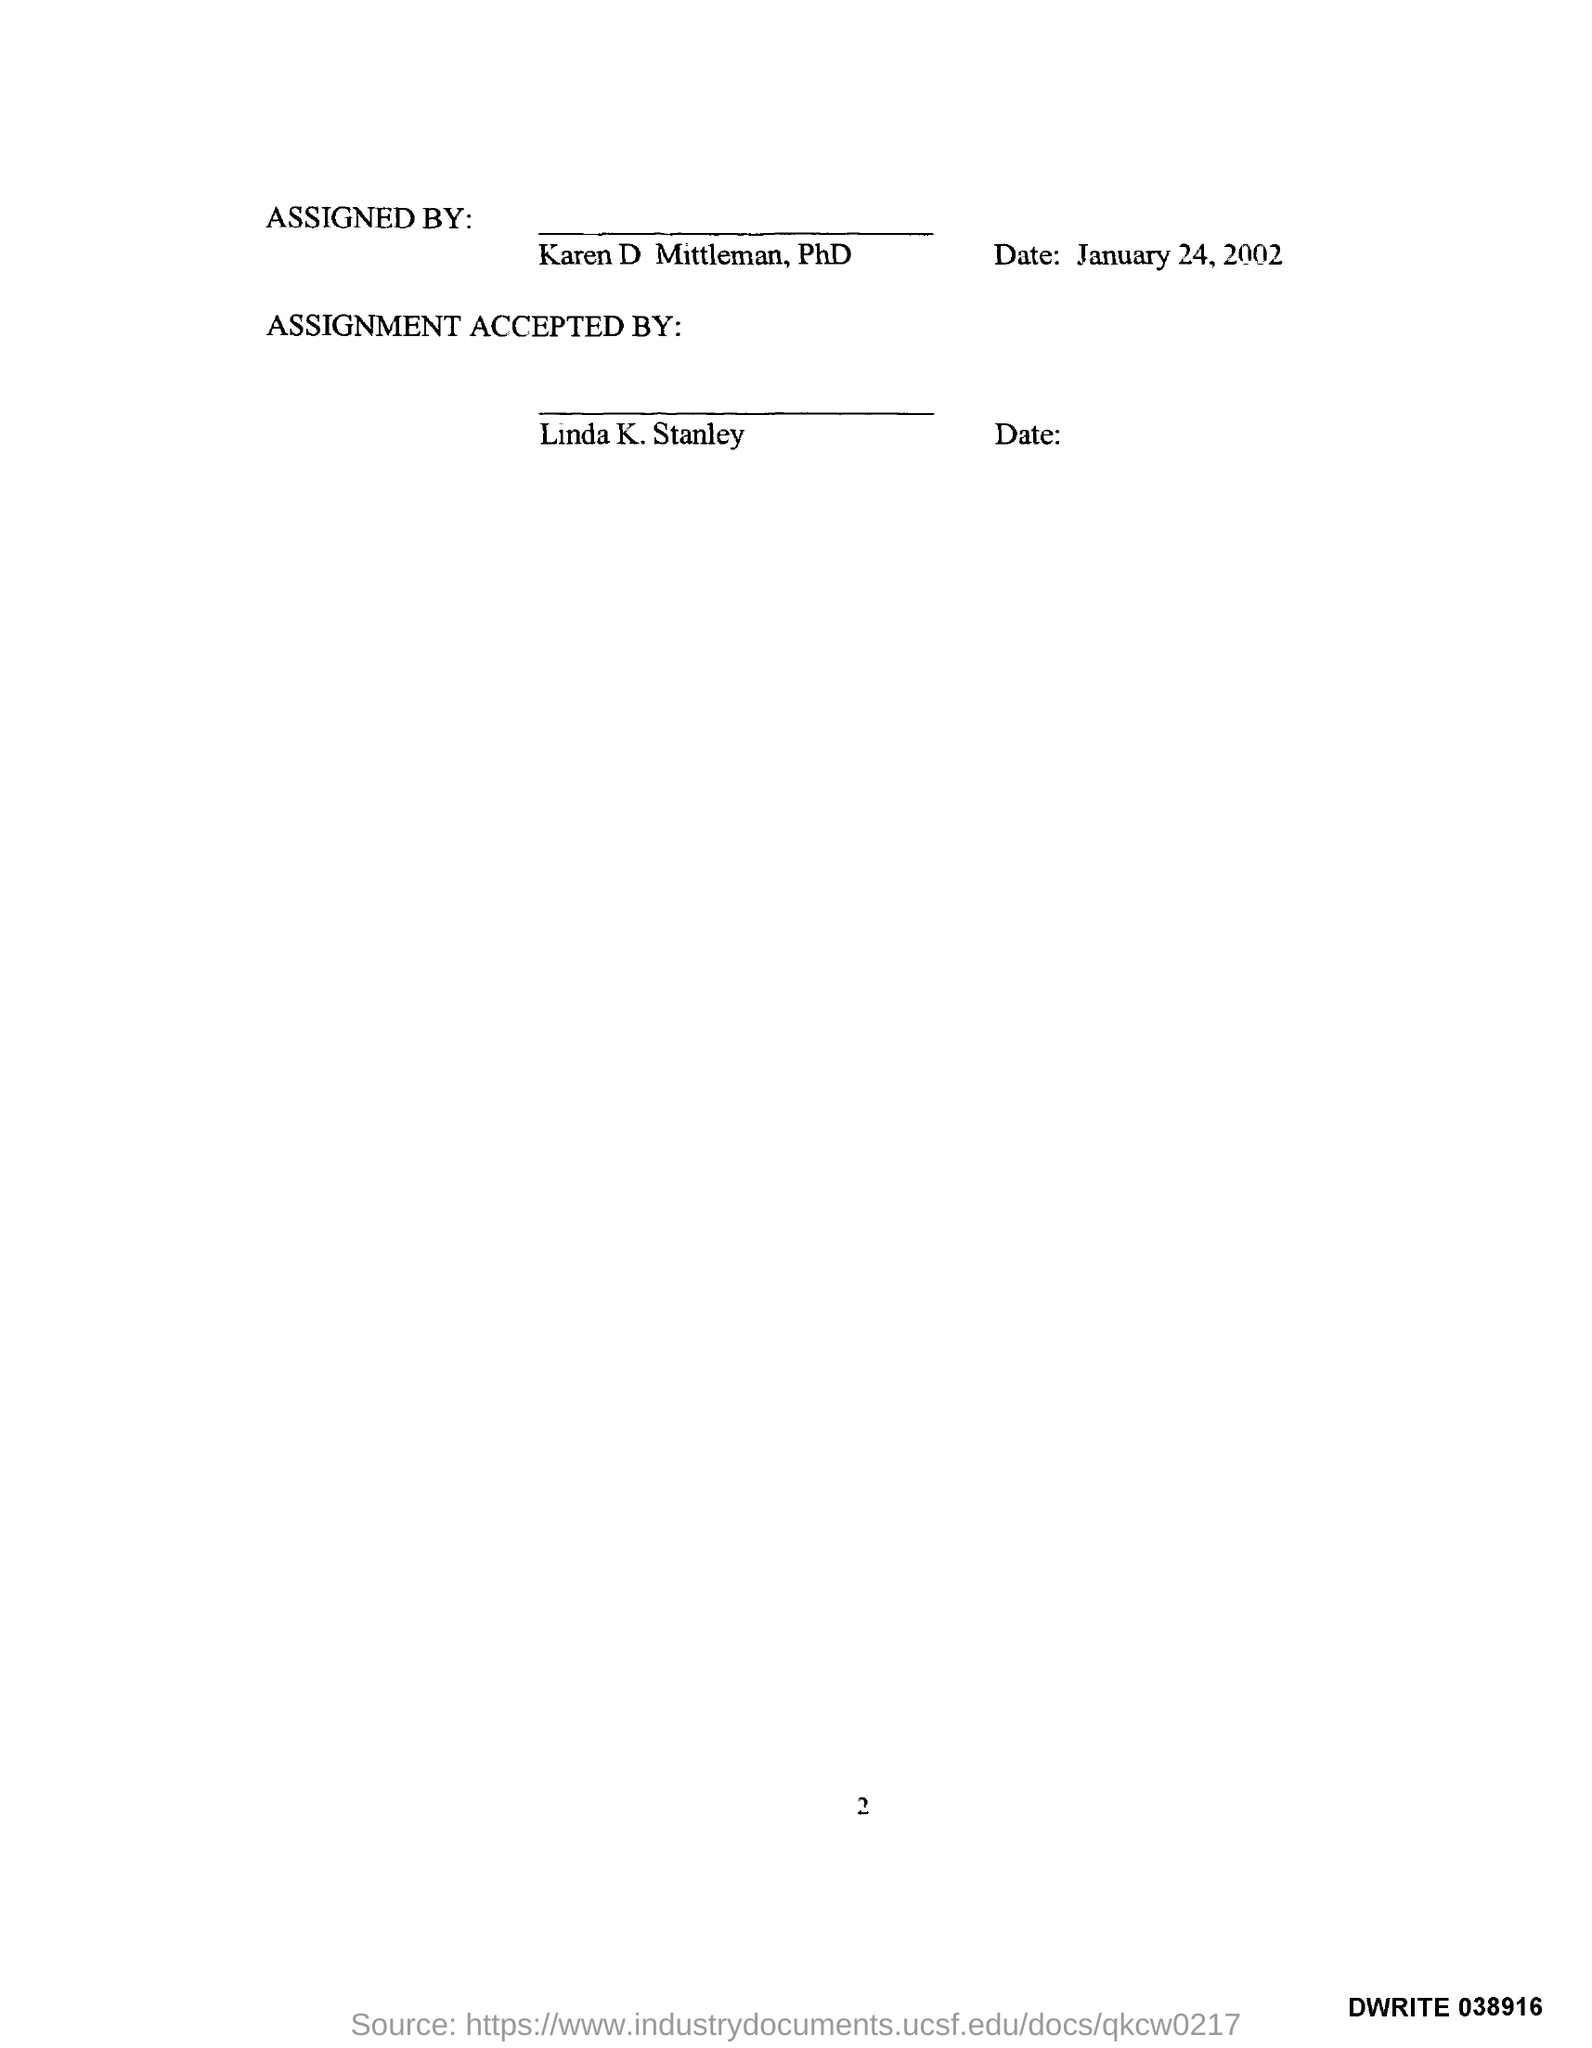Who assigned this document? The document was assigned by Karen D Mittleman, PhD, as per the name written above the 'ASSIGNED BY:' section. Can you describe the positioning of the signatures and dates in relation to the text labels? Certainly. The signatures are located directly on the lines provided below the text labels 'ASSIGNED BY:' and 'ASSIGNMENT ACCEPTED BY:'. The date for when Karen D Mittleman, PhD assigned the document is positioned to the right of her name, whereas the date for Linda K. Stanley's acceptance is intended to be placed to the right of her name, yet it remains unwritten. 